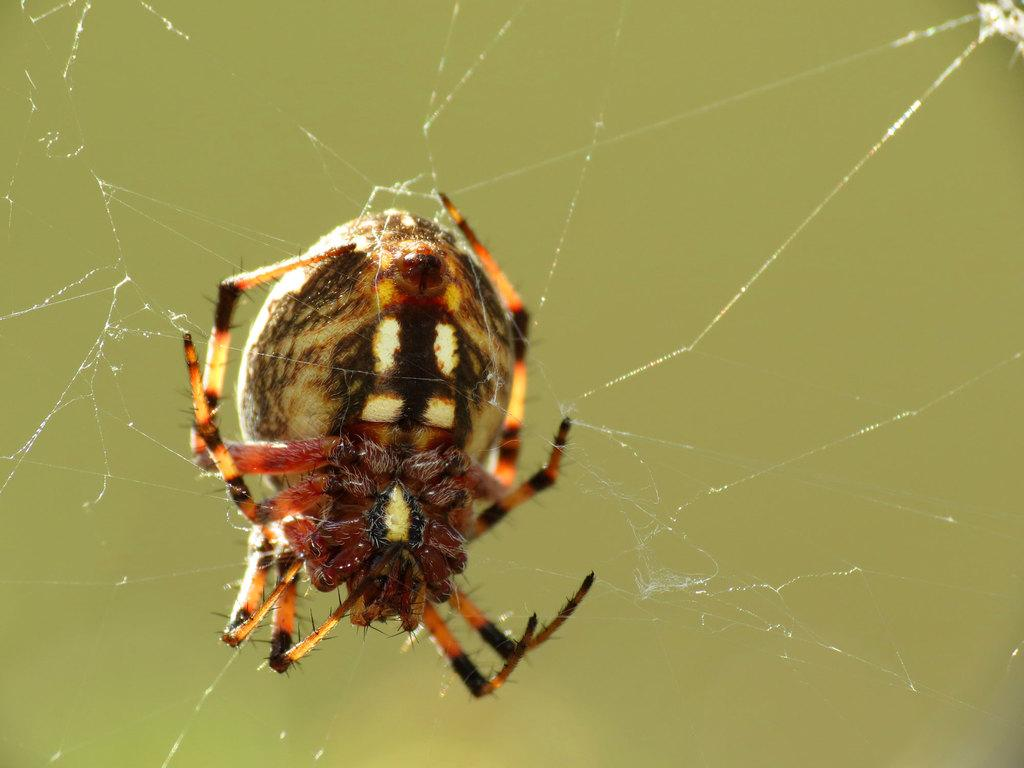What is the main subject of the image? The main subject of the image is a spider. What is the spider associated with in the image? There is a spider web in the image. What type of religious symbol can be seen in the image? There is no religious symbol present in the image; it features a spider and a spider web. What type of cub is visible in the image? There is no cub present in the image; it features a spider and a spider web. 